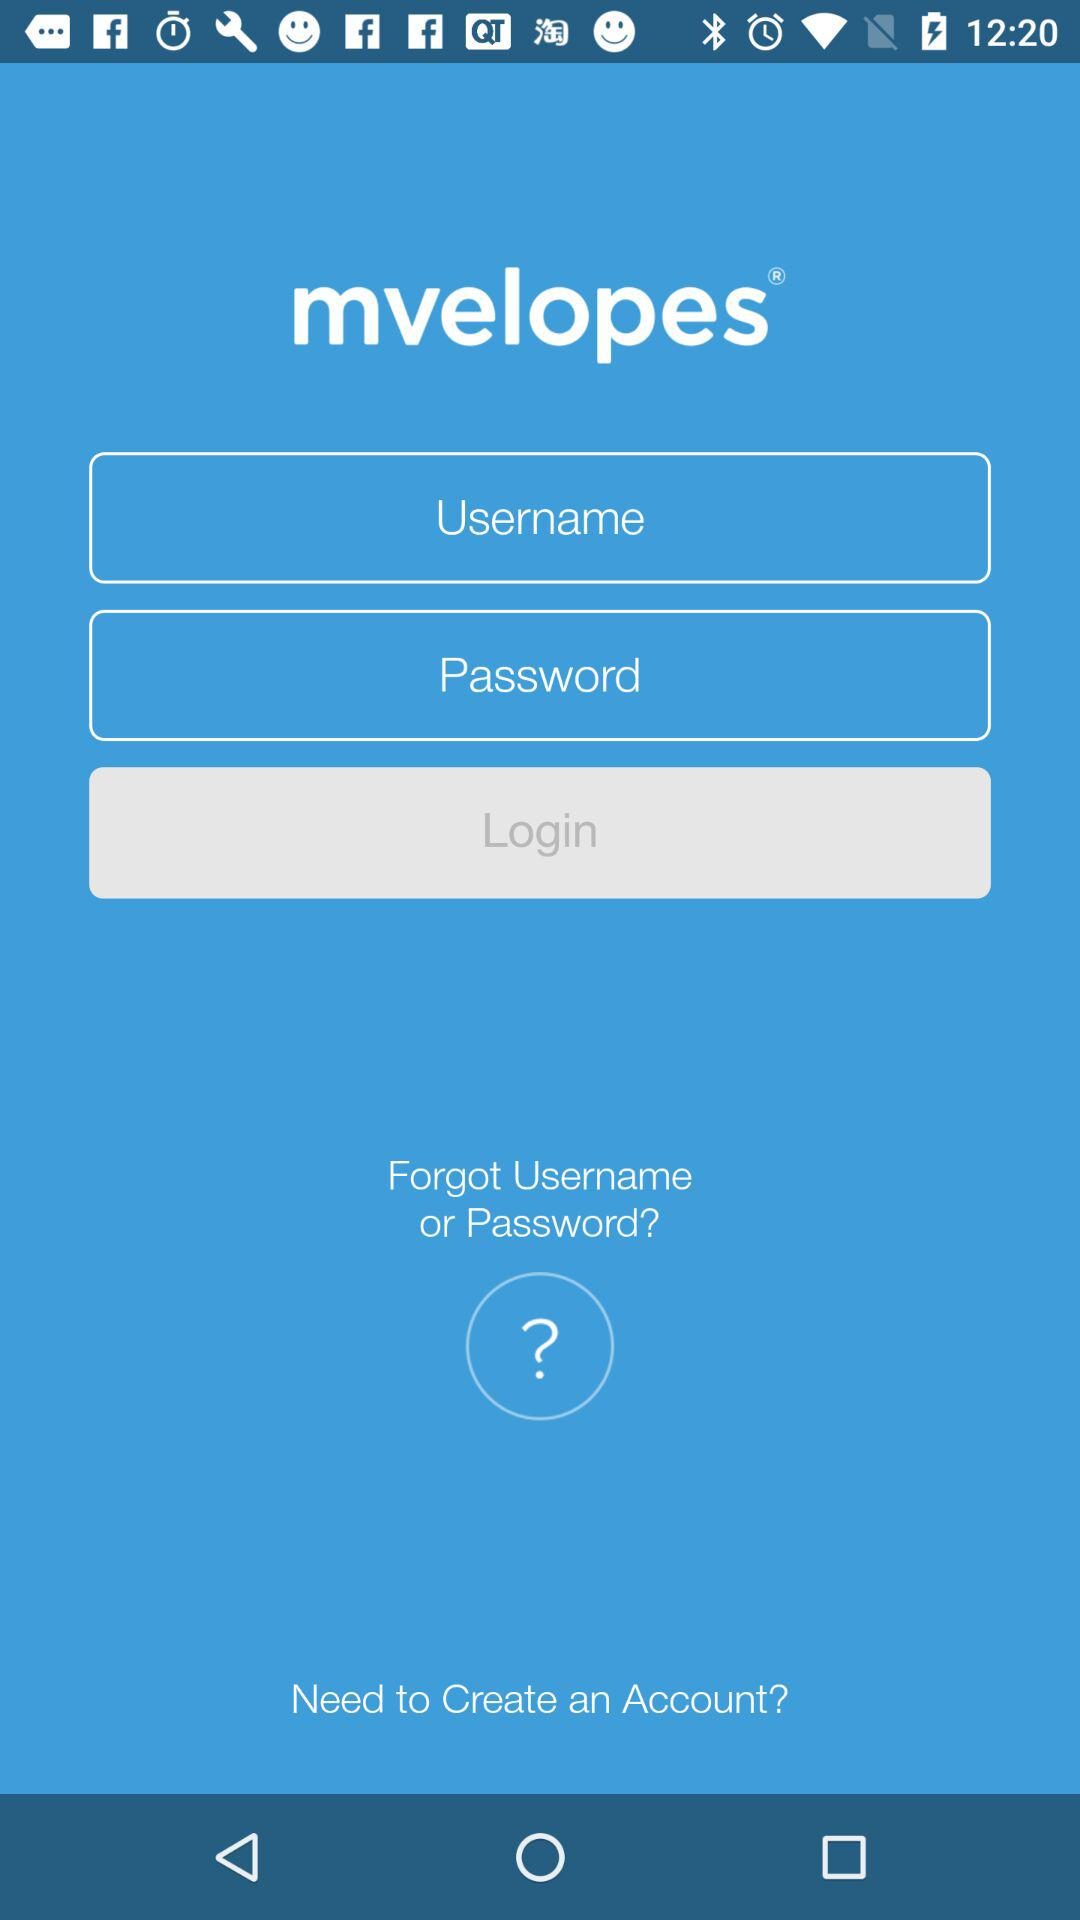What is the username?
When the provided information is insufficient, respond with <no answer>. <no answer> 